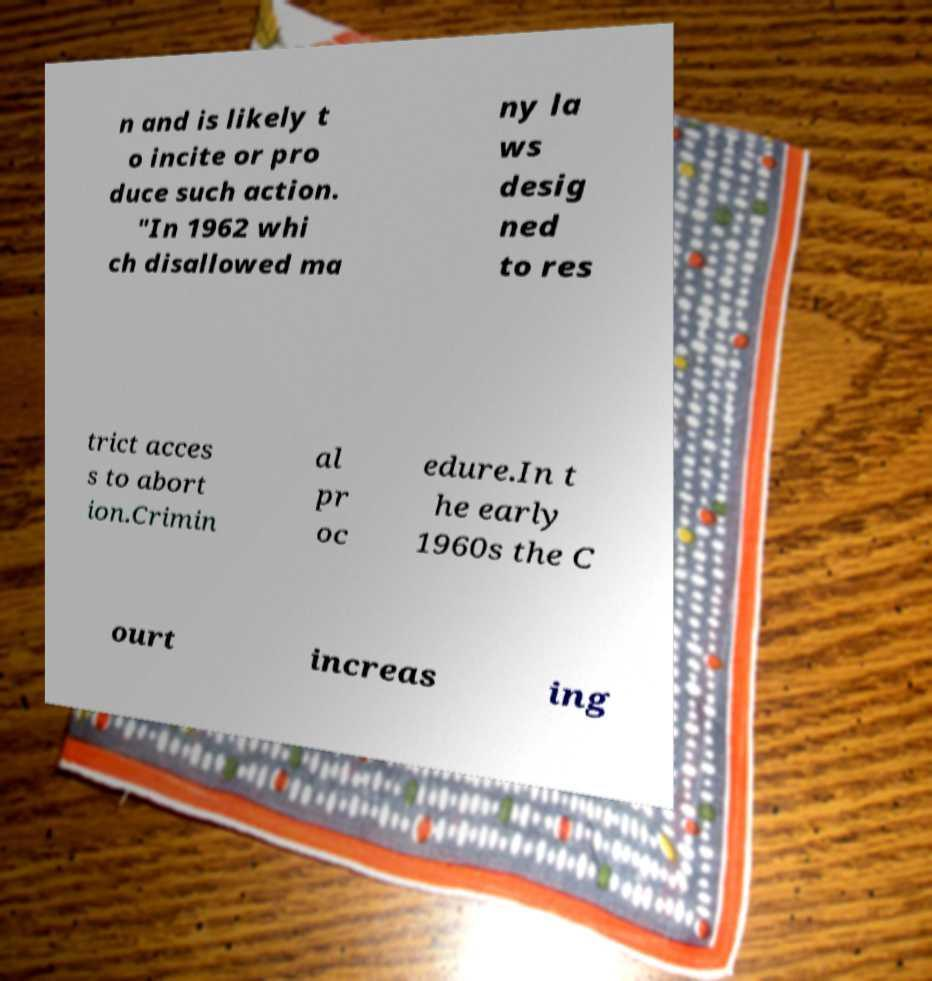Can you accurately transcribe the text from the provided image for me? n and is likely t o incite or pro duce such action. "In 1962 whi ch disallowed ma ny la ws desig ned to res trict acces s to abort ion.Crimin al pr oc edure.In t he early 1960s the C ourt increas ing 